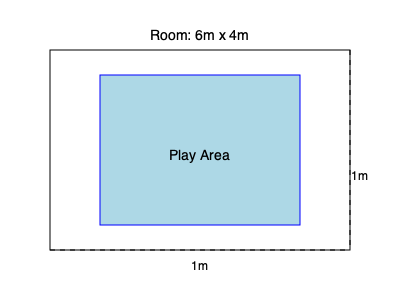You want to create a child-safe play area in your rectangular room that measures 6m by 4m. For safety reasons, you need to leave a 1m gap between the play area and the walls on all sides. What is the maximum area (in square meters) of the play area you can create? To find the maximum area of the play area, we need to follow these steps:

1. Calculate the available dimensions for the play area:
   - Length: $6m - 2m = 4m$ (subtracting 1m from each side)
   - Width: $4m - 2m = 2m$ (subtracting 1m from each side)

2. Calculate the area of the play area:
   Area = Length × Width
   $A = 4m × 2m = 8m^2$

Therefore, the maximum area of the child-safe play area that can be created within the given room layout is 8 square meters.
Answer: $8m^2$ 